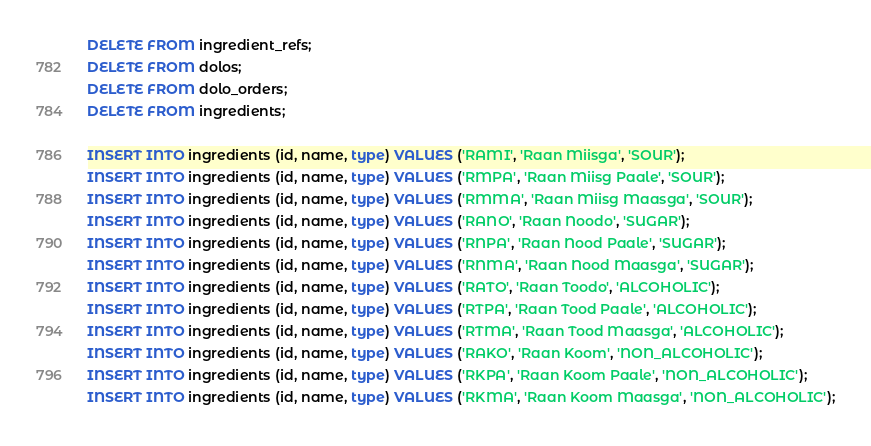<code> <loc_0><loc_0><loc_500><loc_500><_SQL_>DELETE FROM ingredient_refs;
DELETE FROM dolos;
DELETE FROM dolo_orders;
DELETE FROM ingredients;

INSERT INTO ingredients (id, name, type) VALUES ('RAMI', 'Raan Miisga', 'SOUR');
INSERT INTO ingredients (id, name, type) VALUES ('RMPA', 'Raan Miisg Paale', 'SOUR');
INSERT INTO ingredients (id, name, type) VALUES ('RMMA', 'Raan Miisg Maasga', 'SOUR');
INSERT INTO ingredients (id, name, type) VALUES ('RANO', 'Raan Noodo', 'SUGAR');
INSERT INTO ingredients (id, name, type) VALUES ('RNPA', 'Raan Nood Paale', 'SUGAR');
INSERT INTO ingredients (id, name, type) VALUES ('RNMA', 'Raan Nood Maasga', 'SUGAR');
INSERT INTO ingredients (id, name, type) VALUES ('RATO', 'Raan Toodo', 'ALCOHOLIC');
INSERT INTO ingredients (id, name, type) VALUES ('RTPA', 'Raan Tood Paale', 'ALCOHOLIC');
INSERT INTO ingredients (id, name, type) VALUES ('RTMA', 'Raan Tood Maasga', 'ALCOHOLIC');
INSERT INTO ingredients (id, name, type) VALUES ('RAKO', 'Raan Koom', 'NON_ALCOHOLIC');
INSERT INTO ingredients (id, name, type) VALUES ('RKPA', 'Raan Koom Paale', 'NON_ALCOHOLIC');
INSERT INTO ingredients (id, name, type) VALUES ('RKMA', 'Raan Koom Maasga', 'NON_ALCOHOLIC');</code> 